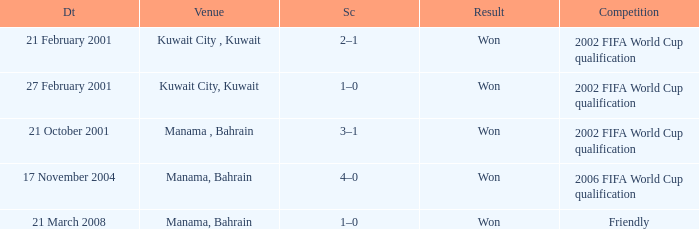On which date was the 2006 FIFA World Cup Qualification in Manama, Bahrain? 17 November 2004. Parse the table in full. {'header': ['Dt', 'Venue', 'Sc', 'Result', 'Competition'], 'rows': [['21 February 2001', 'Kuwait City , Kuwait', '2–1', 'Won', '2002 FIFA World Cup qualification'], ['27 February 2001', 'Kuwait City, Kuwait', '1–0', 'Won', '2002 FIFA World Cup qualification'], ['21 October 2001', 'Manama , Bahrain', '3–1', 'Won', '2002 FIFA World Cup qualification'], ['17 November 2004', 'Manama, Bahrain', '4–0', 'Won', '2006 FIFA World Cup qualification'], ['21 March 2008', 'Manama, Bahrain', '1–0', 'Won', 'Friendly']]} 